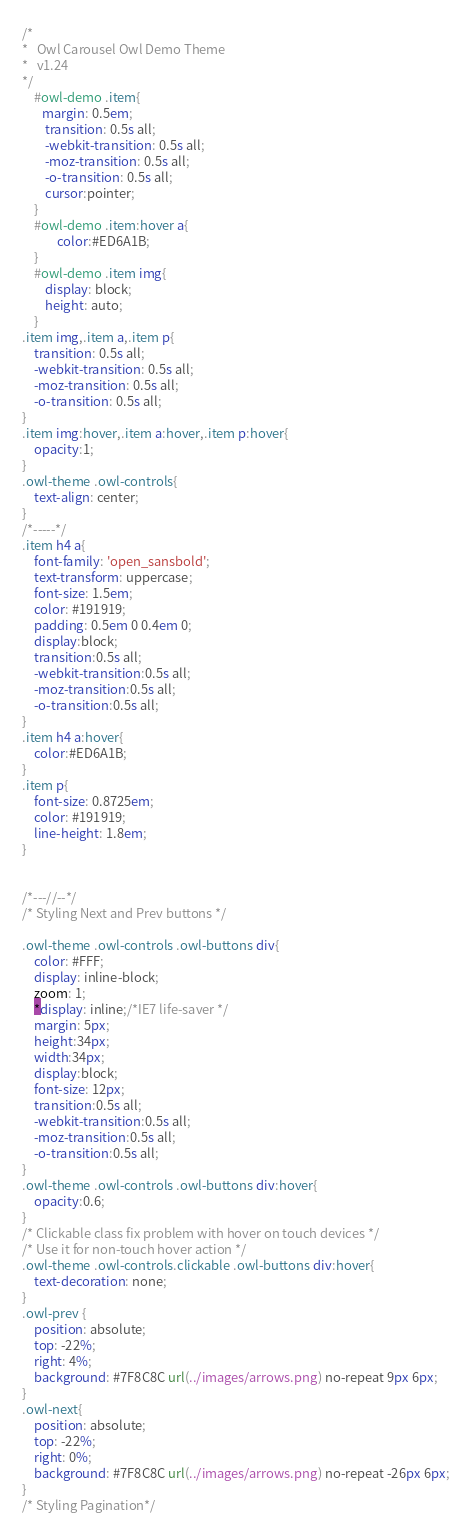<code> <loc_0><loc_0><loc_500><loc_500><_CSS_>/*
* 	Owl Carousel Owl Demo Theme 
*	v1.24
*/
    #owl-demo .item{
       margin: 0.5em;
		transition: 0.5s all;
		-webkit-transition: 0.5s all;
		-moz-transition: 0.5s all;
		-o-transition: 0.5s all;
		cursor:pointer;
    }
    #owl-demo .item:hover a{
    		color:#ED6A1B;
    }
    #owl-demo .item img{
        display: block;
        height: auto;
    }
.item img,.item a,.item p{
	transition: 0.5s all;
	-webkit-transition: 0.5s all;
	-moz-transition: 0.5s all;
	-o-transition: 0.5s all;
}
.item img:hover,.item a:hover,.item p:hover{
	opacity:1;
}
.owl-theme .owl-controls{
	text-align: center;
}
/*-----*/
.item h4 a{
	font-family: 'open_sansbold';
	text-transform: uppercase;
	font-size: 1.5em;
	color: #191919;
	padding: 0.5em 0 0.4em 0;
	display:block;
	transition:0.5s all;
    -webkit-transition:0.5s all;
    -moz-transition:0.5s all;
    -o-transition:0.5s all;
}
.item h4 a:hover{
	color:#ED6A1B;
}
.item p{
	font-size: 0.8725em;
	color: #191919;
	line-height: 1.8em;
}


/*---//--*/
/* Styling Next and Prev buttons */

.owl-theme .owl-controls .owl-buttons div{
	color: #FFF;
	display: inline-block;
	zoom: 1;
	*display: inline;/*IE7 life-saver */
	margin: 5px;
	height:34px;
	width:34px;
	display:block;
	font-size: 12px;
	transition:0.5s all;
    -webkit-transition:0.5s all;
    -moz-transition:0.5s all;
    -o-transition:0.5s all;
}
.owl-theme .owl-controls .owl-buttons div:hover{
	opacity:0.6;
}
/* Clickable class fix problem with hover on touch devices */
/* Use it for non-touch hover action */
.owl-theme .owl-controls.clickable .owl-buttons div:hover{
	text-decoration: none;
}
.owl-prev {
	position: absolute;
	top: -22%;
	right: 4%;
	background: #7F8C8C url(../images/arrows.png) no-repeat 9px 6px;
}
.owl-next{
	position: absolute;
	top: -22%;
	right: 0%;
	background: #7F8C8C url(../images/arrows.png) no-repeat -26px 6px;
}
/* Styling Pagination*/
</code> 